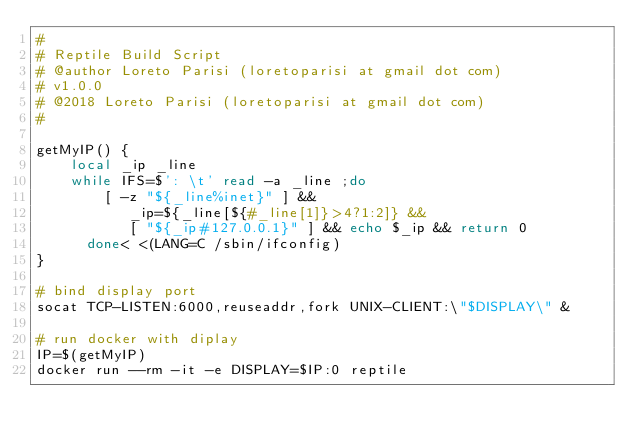Convert code to text. <code><loc_0><loc_0><loc_500><loc_500><_Bash_>#
# Reptile Build Script
# @author Loreto Parisi (loretoparisi at gmail dot com)
# v1.0.0
# @2018 Loreto Parisi (loretoparisi at gmail dot com)
#

getMyIP() {
    local _ip _line
    while IFS=$': \t' read -a _line ;do
        [ -z "${_line%inet}" ] &&
           _ip=${_line[${#_line[1]}>4?1:2]} &&
           [ "${_ip#127.0.0.1}" ] && echo $_ip && return 0
      done< <(LANG=C /sbin/ifconfig)
}

# bind display port
socat TCP-LISTEN:6000,reuseaddr,fork UNIX-CLIENT:\"$DISPLAY\" &

# run docker with diplay
IP=$(getMyIP)
docker run --rm -it -e DISPLAY=$IP:0 reptile</code> 